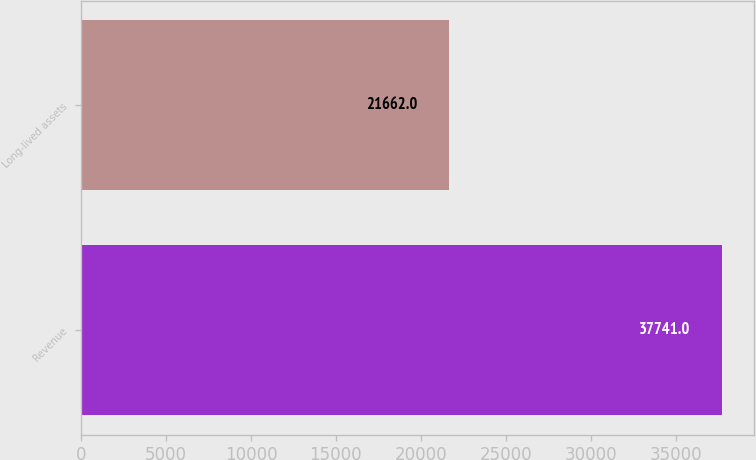Convert chart to OTSL. <chart><loc_0><loc_0><loc_500><loc_500><bar_chart><fcel>Revenue<fcel>Long-lived assets<nl><fcel>37741<fcel>21662<nl></chart> 